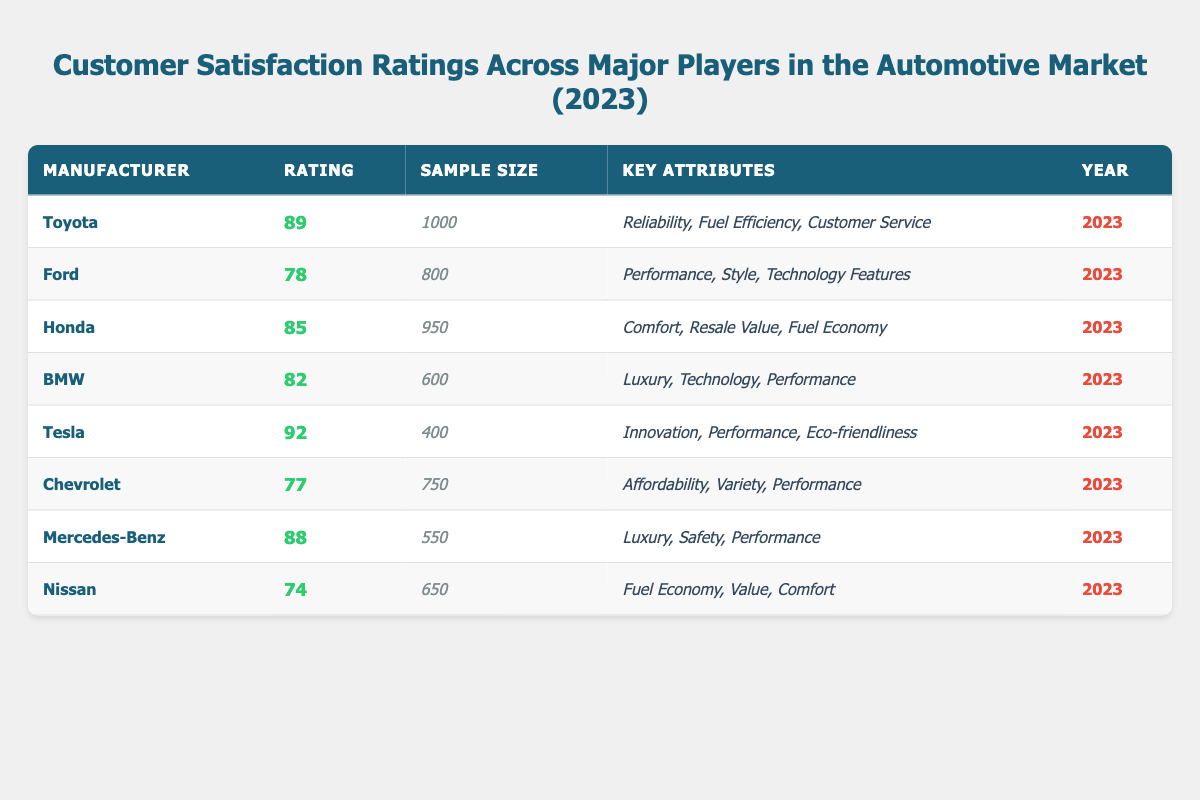What is the customer satisfaction rating for Toyota? According to the table, the customer satisfaction rating for Toyota is listed directly as 89.
Answer: 89 How many manufacturers have a customer satisfaction rating above 85? The manufacturers with ratings above 85 are Toyota (89), Honda (85), and Tesla (92), which totals 3 manufacturers.
Answer: 3 What is the average customer satisfaction rating of all manufacturers listed? The ratings are 89, 78, 85, 82, 92, 77, 88, 74. Summing them gives 89 + 78 + 85 + 82 + 92 + 77 + 88 + 74 = 685, and dividing by 8 manufacturers gives an average of 685 / 8 = 85.625.
Answer: 85.625 Which manufacturer has the highest customer satisfaction rating and what is that rating? The highest rating in the table is 92, attributed to Tesla.
Answer: Tesla, 92 Is it true that Chevrolet has a higher satisfaction rating than Nissan? The satisfaction rating for Chevrolet is 77, while for Nissan it is 74; therefore, it's true that Chevrolet has a higher rating than Nissan.
Answer: True What is the difference in customer satisfaction ratings between Tesla and BMW? Tesla has a rating of 92, and BMW has a rating of 82. The difference is 92 - 82 = 10.
Answer: 10 How many manufacturers have a sample size of less than 700? The sample sizes are: Toyota (1000), Ford (800), Honda (950), BMW (600), Tesla (400), Chevrolet (750), Mercedes-Benz (550), and Nissan (650). The manufacturers with less than 700 are Tesla (400), BMW (600), and Mercedes-Benz (550), totaling 3 manufacturers.
Answer: 3 Which manufacturer has the key attributes related to "Luxury, Safety, Performance"? According to the table, Mercedes-Benz is associated with the key attributes of "Luxury, Safety, Performance."
Answer: Mercedes-Benz What is the relationship between sample size and customer satisfaction rating for all manufacturers? By examining the table, there's no direct indication of a consistent relationship; for example, Toyota, with a larger sample size (1000), has a high rating (89), while Tesla, with a smaller sample size (400), has the highest rating (92).
Answer: No consistent relationship Which manufacturer has the lowest customer satisfaction rating, and what is that rating? The manufacturer with the lowest rating is Nissan, with a satisfaction rating of 74.
Answer: Nissan, 74 